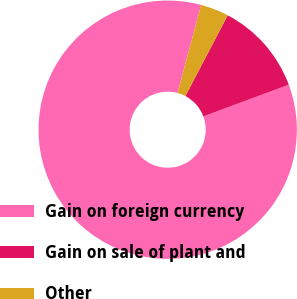Convert chart. <chart><loc_0><loc_0><loc_500><loc_500><pie_chart><fcel>Gain on foreign currency<fcel>Gain on sale of plant and<fcel>Other<nl><fcel>84.83%<fcel>11.65%<fcel>3.52%<nl></chart> 